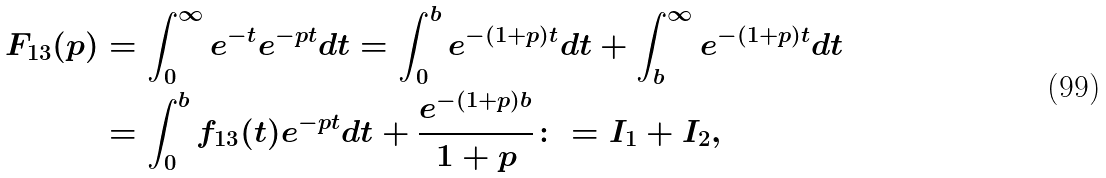<formula> <loc_0><loc_0><loc_500><loc_500>F _ { 1 3 } ( p ) & = \int _ { 0 } ^ { \infty } e ^ { - t } e ^ { - p t } d t = \int _ { 0 } ^ { b } e ^ { - ( 1 + p ) t } d t + \int _ { b } ^ { \infty } e ^ { - ( 1 + p ) t } d t \\ & = \int _ { 0 } ^ { b } f _ { 1 3 } ( t ) e ^ { - p t } d t + \frac { e ^ { - ( 1 + p ) b } } { 1 + p } \colon = I _ { 1 } + I _ { 2 } ,</formula> 